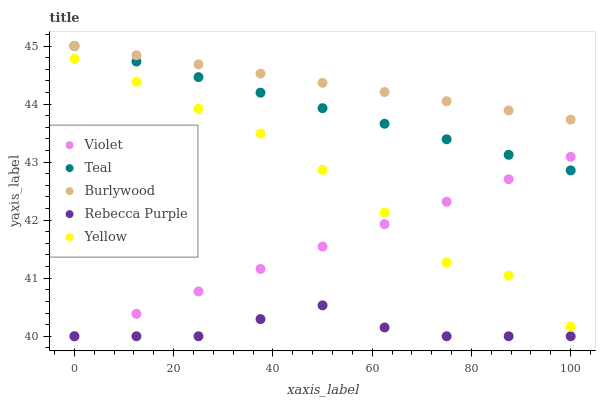Does Rebecca Purple have the minimum area under the curve?
Answer yes or no. Yes. Does Burlywood have the maximum area under the curve?
Answer yes or no. Yes. Does Yellow have the minimum area under the curve?
Answer yes or no. No. Does Yellow have the maximum area under the curve?
Answer yes or no. No. Is Burlywood the smoothest?
Answer yes or no. Yes. Is Yellow the roughest?
Answer yes or no. Yes. Is Rebecca Purple the smoothest?
Answer yes or no. No. Is Rebecca Purple the roughest?
Answer yes or no. No. Does Rebecca Purple have the lowest value?
Answer yes or no. Yes. Does Yellow have the lowest value?
Answer yes or no. No. Does Teal have the highest value?
Answer yes or no. Yes. Does Yellow have the highest value?
Answer yes or no. No. Is Rebecca Purple less than Teal?
Answer yes or no. Yes. Is Burlywood greater than Yellow?
Answer yes or no. Yes. Does Violet intersect Yellow?
Answer yes or no. Yes. Is Violet less than Yellow?
Answer yes or no. No. Is Violet greater than Yellow?
Answer yes or no. No. Does Rebecca Purple intersect Teal?
Answer yes or no. No. 